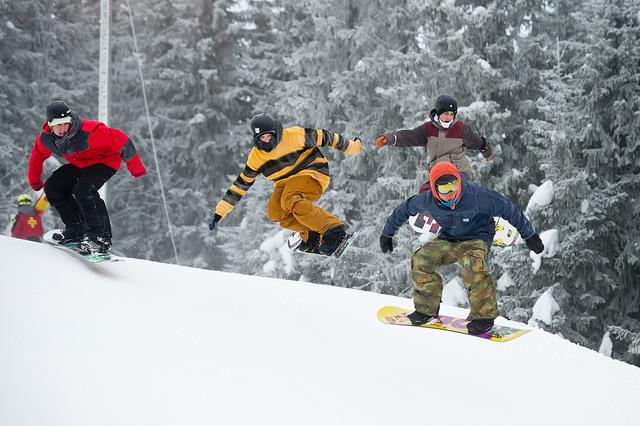The middle athlete looks like an what? Please explain your reasoning. bee. He has a striped shirt on that is yellow and black. 